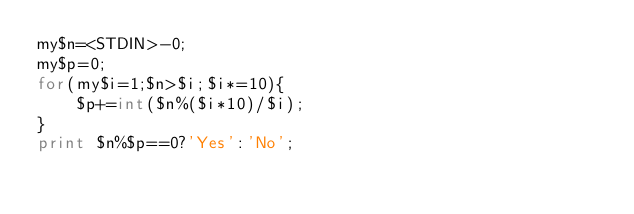<code> <loc_0><loc_0><loc_500><loc_500><_Perl_>my$n=<STDIN>-0;
my$p=0;
for(my$i=1;$n>$i;$i*=10){
    $p+=int($n%($i*10)/$i);
}
print $n%$p==0?'Yes':'No';</code> 